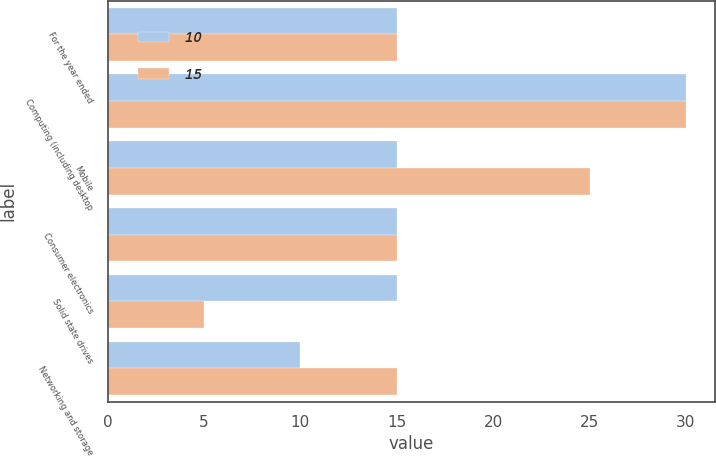Convert chart to OTSL. <chart><loc_0><loc_0><loc_500><loc_500><stacked_bar_chart><ecel><fcel>For the year ended<fcel>Computing (including desktop<fcel>Mobile<fcel>Consumer electronics<fcel>Solid state drives<fcel>Networking and storage<nl><fcel>10<fcel>15<fcel>30<fcel>15<fcel>15<fcel>15<fcel>10<nl><fcel>15<fcel>15<fcel>30<fcel>25<fcel>15<fcel>5<fcel>15<nl></chart> 